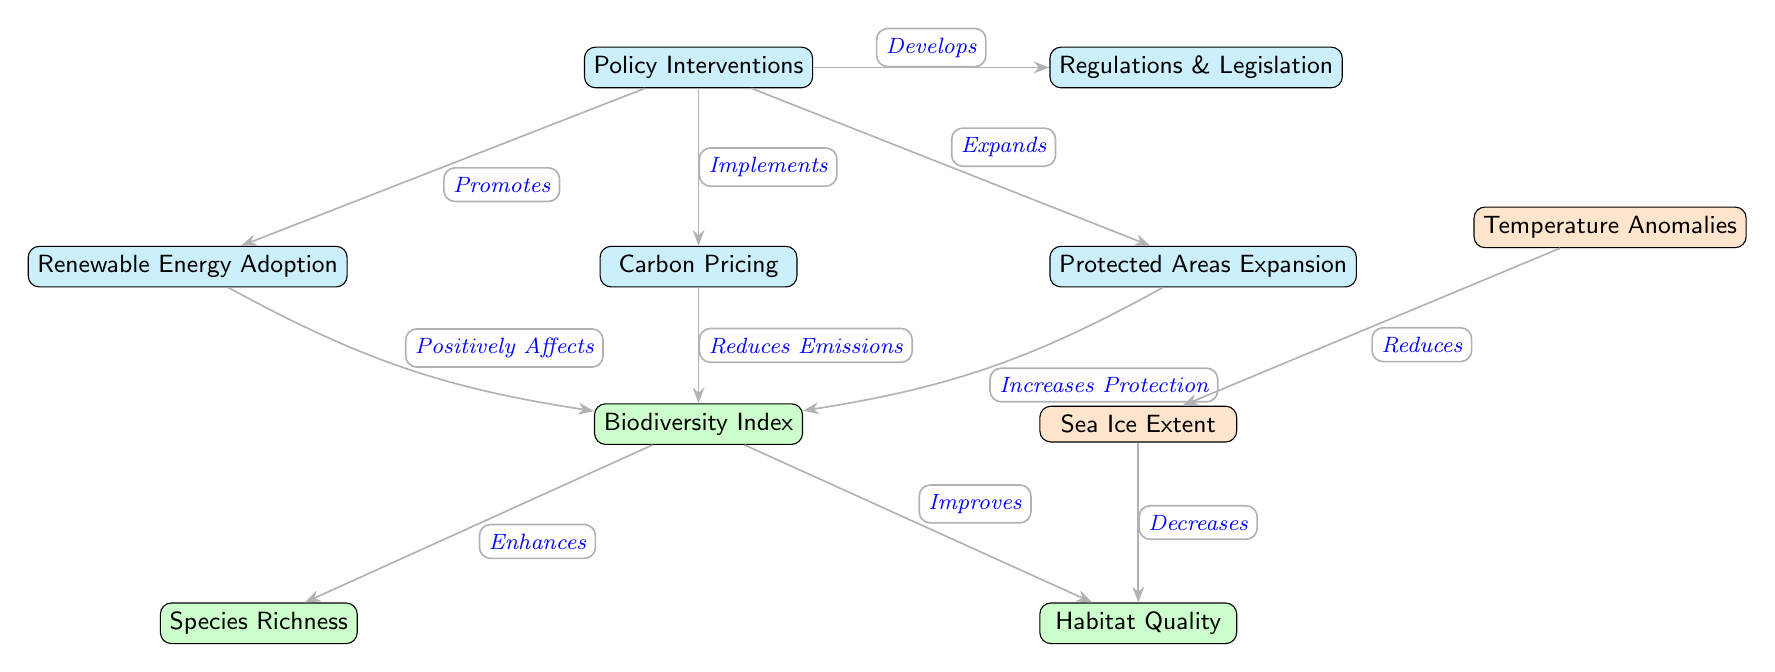What are the four policy interventions depicted in the diagram? The diagram shows four policy interventions: Renewable Energy Adoption, Carbon Pricing, Protected Areas Expansion, and Regulations & Legislation. Each node representing these interventions is directly connected to the main Policy Interventions node.
Answer: Renewable Energy Adoption, Carbon Pricing, Protected Areas Expansion, Regulations & Legislation How does Renewable Energy Adoption affect the Biodiversity Index? According to the diagram, Renewable Energy Adoption is connected to the Biodiversity Index with the relationship "Positively Affects," indicating that this intervention has a beneficial impact on biodiversity.
Answer: Positively Affects What is the relationship between Protected Areas Expansion and the Biodiversity Index? The diagram shows that Protected Areas Expansion "Increases Protection" of the Biodiversity Index. This means that expanding protected areas contributes positively to preserving biodiversity.
Answer: Increases Protection What is the effect of Temperature Anomalies on Sea Ice Extent? The diagram illustrates that Temperature Anomalies lead to a "Reduces" relationship with Sea Ice Extent, meaning that increases in temperature anomalies negatively impact the amount of sea ice.
Answer: Reduces Which intervention shows a direct connection to Species Richness? The Biodiversity Index node connects to Species Richness with the label "Enhances," indicating that the Biodiversity Index, influenced by different interventions, improves species richness.
Answer: Enhances What is the connection between the Biodiversity Index and Habitat Quality? The diagram indicates that Biodiversity Index "Improves" Habitat Quality, signifying that enhancements in biodiversity contribute to better habitat conditions.
Answer: Improves How many nodes represent biodiversity-related elements? There are three nodes dedicated to biodiversity-related aspects in the diagram: Biodiversity Index, Species Richness, and Habitat Quality. Counting these nodes gives the total number of biodiversity elements represented.
Answer: Three What is the indirect effect of Carbon Pricing on Habitat Quality? To determine this, we trace the effects starting from Carbon Pricing, which "Reduces Emissions" affecting the Biodiversity Index. The Biodiversity Index then "Improves" Habitat Quality. Thus, the indirect effect can be interpreted through these connections.
Answer: Improves 